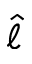Convert formula to latex. <formula><loc_0><loc_0><loc_500><loc_500>\hat { \ell }</formula> 